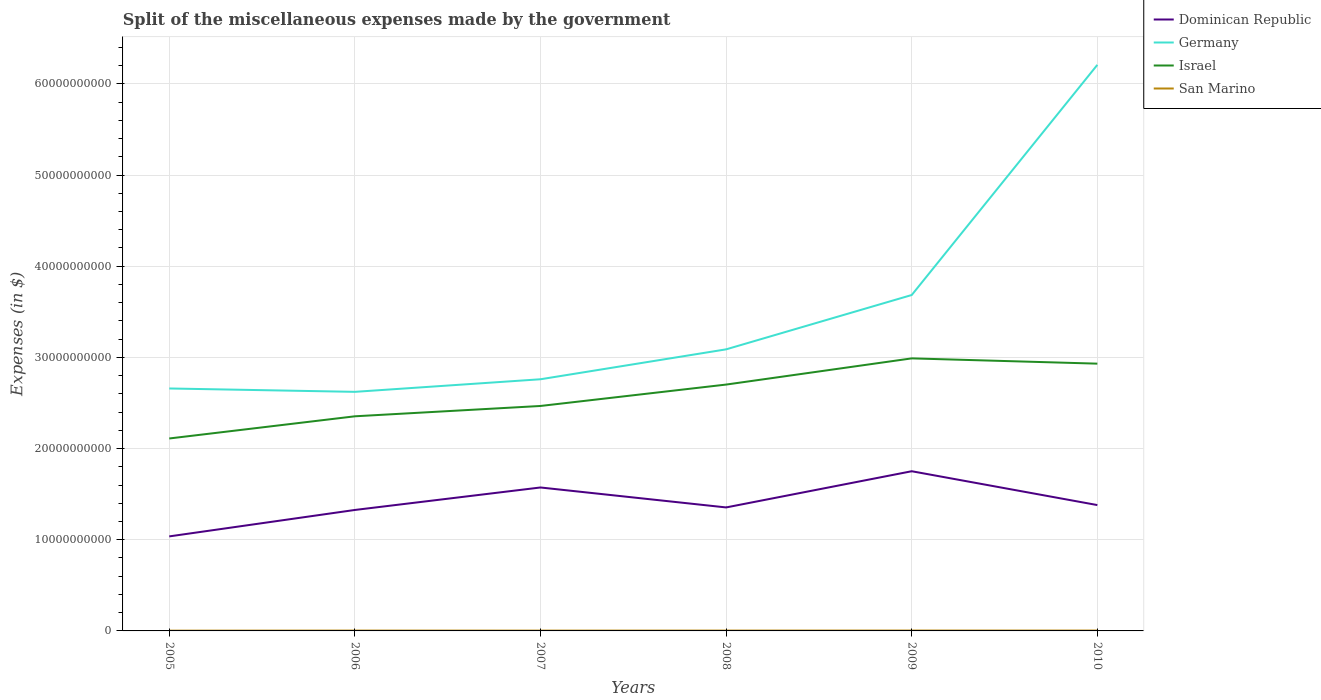Across all years, what is the maximum miscellaneous expenses made by the government in Dominican Republic?
Provide a succinct answer. 1.04e+1. In which year was the miscellaneous expenses made by the government in San Marino maximum?
Offer a very short reply. 2005. What is the total miscellaneous expenses made by the government in Germany in the graph?
Provide a short and direct response. 3.70e+08. What is the difference between the highest and the second highest miscellaneous expenses made by the government in Israel?
Offer a very short reply. 8.79e+09. What is the difference between the highest and the lowest miscellaneous expenses made by the government in Dominican Republic?
Provide a succinct answer. 2. Are the values on the major ticks of Y-axis written in scientific E-notation?
Give a very brief answer. No. Does the graph contain any zero values?
Your answer should be very brief. No. Where does the legend appear in the graph?
Offer a terse response. Top right. How are the legend labels stacked?
Offer a terse response. Vertical. What is the title of the graph?
Keep it short and to the point. Split of the miscellaneous expenses made by the government. What is the label or title of the X-axis?
Provide a short and direct response. Years. What is the label or title of the Y-axis?
Make the answer very short. Expenses (in $). What is the Expenses (in $) in Dominican Republic in 2005?
Your answer should be compact. 1.04e+1. What is the Expenses (in $) in Germany in 2005?
Keep it short and to the point. 2.66e+1. What is the Expenses (in $) in Israel in 2005?
Offer a terse response. 2.11e+1. What is the Expenses (in $) in San Marino in 2005?
Offer a very short reply. 2.95e+07. What is the Expenses (in $) of Dominican Republic in 2006?
Ensure brevity in your answer.  1.33e+1. What is the Expenses (in $) in Germany in 2006?
Your answer should be compact. 2.62e+1. What is the Expenses (in $) of Israel in 2006?
Ensure brevity in your answer.  2.35e+1. What is the Expenses (in $) in San Marino in 2006?
Provide a short and direct response. 3.73e+07. What is the Expenses (in $) in Dominican Republic in 2007?
Your answer should be very brief. 1.57e+1. What is the Expenses (in $) in Germany in 2007?
Your answer should be compact. 2.76e+1. What is the Expenses (in $) in Israel in 2007?
Provide a short and direct response. 2.47e+1. What is the Expenses (in $) in San Marino in 2007?
Your response must be concise. 3.50e+07. What is the Expenses (in $) in Dominican Republic in 2008?
Your answer should be very brief. 1.35e+1. What is the Expenses (in $) of Germany in 2008?
Offer a very short reply. 3.09e+1. What is the Expenses (in $) of Israel in 2008?
Provide a short and direct response. 2.70e+1. What is the Expenses (in $) in San Marino in 2008?
Your response must be concise. 3.81e+07. What is the Expenses (in $) of Dominican Republic in 2009?
Offer a terse response. 1.75e+1. What is the Expenses (in $) of Germany in 2009?
Ensure brevity in your answer.  3.68e+1. What is the Expenses (in $) in Israel in 2009?
Your answer should be compact. 2.99e+1. What is the Expenses (in $) of San Marino in 2009?
Offer a terse response. 4.16e+07. What is the Expenses (in $) in Dominican Republic in 2010?
Your response must be concise. 1.38e+1. What is the Expenses (in $) in Germany in 2010?
Offer a terse response. 6.21e+1. What is the Expenses (in $) in Israel in 2010?
Your answer should be very brief. 2.93e+1. What is the Expenses (in $) in San Marino in 2010?
Your response must be concise. 4.00e+07. Across all years, what is the maximum Expenses (in $) in Dominican Republic?
Offer a very short reply. 1.75e+1. Across all years, what is the maximum Expenses (in $) of Germany?
Ensure brevity in your answer.  6.21e+1. Across all years, what is the maximum Expenses (in $) of Israel?
Offer a terse response. 2.99e+1. Across all years, what is the maximum Expenses (in $) of San Marino?
Give a very brief answer. 4.16e+07. Across all years, what is the minimum Expenses (in $) of Dominican Republic?
Make the answer very short. 1.04e+1. Across all years, what is the minimum Expenses (in $) in Germany?
Provide a short and direct response. 2.62e+1. Across all years, what is the minimum Expenses (in $) in Israel?
Ensure brevity in your answer.  2.11e+1. Across all years, what is the minimum Expenses (in $) in San Marino?
Your answer should be compact. 2.95e+07. What is the total Expenses (in $) of Dominican Republic in the graph?
Give a very brief answer. 8.42e+1. What is the total Expenses (in $) in Germany in the graph?
Provide a short and direct response. 2.10e+11. What is the total Expenses (in $) in Israel in the graph?
Offer a very short reply. 1.56e+11. What is the total Expenses (in $) of San Marino in the graph?
Your answer should be compact. 2.22e+08. What is the difference between the Expenses (in $) in Dominican Republic in 2005 and that in 2006?
Offer a very short reply. -2.90e+09. What is the difference between the Expenses (in $) of Germany in 2005 and that in 2006?
Provide a succinct answer. 3.70e+08. What is the difference between the Expenses (in $) of Israel in 2005 and that in 2006?
Keep it short and to the point. -2.43e+09. What is the difference between the Expenses (in $) in San Marino in 2005 and that in 2006?
Offer a terse response. -7.72e+06. What is the difference between the Expenses (in $) in Dominican Republic in 2005 and that in 2007?
Your answer should be compact. -5.36e+09. What is the difference between the Expenses (in $) in Germany in 2005 and that in 2007?
Offer a terse response. -1.01e+09. What is the difference between the Expenses (in $) of Israel in 2005 and that in 2007?
Your answer should be compact. -3.57e+09. What is the difference between the Expenses (in $) in San Marino in 2005 and that in 2007?
Ensure brevity in your answer.  -5.46e+06. What is the difference between the Expenses (in $) of Dominican Republic in 2005 and that in 2008?
Provide a short and direct response. -3.18e+09. What is the difference between the Expenses (in $) in Germany in 2005 and that in 2008?
Offer a terse response. -4.29e+09. What is the difference between the Expenses (in $) in Israel in 2005 and that in 2008?
Your answer should be very brief. -5.91e+09. What is the difference between the Expenses (in $) in San Marino in 2005 and that in 2008?
Provide a succinct answer. -8.61e+06. What is the difference between the Expenses (in $) of Dominican Republic in 2005 and that in 2009?
Your answer should be very brief. -7.15e+09. What is the difference between the Expenses (in $) in Germany in 2005 and that in 2009?
Your answer should be compact. -1.02e+1. What is the difference between the Expenses (in $) in Israel in 2005 and that in 2009?
Your answer should be compact. -8.79e+09. What is the difference between the Expenses (in $) of San Marino in 2005 and that in 2009?
Provide a succinct answer. -1.21e+07. What is the difference between the Expenses (in $) of Dominican Republic in 2005 and that in 2010?
Your answer should be very brief. -3.43e+09. What is the difference between the Expenses (in $) of Germany in 2005 and that in 2010?
Offer a terse response. -3.55e+1. What is the difference between the Expenses (in $) of Israel in 2005 and that in 2010?
Ensure brevity in your answer.  -8.21e+09. What is the difference between the Expenses (in $) in San Marino in 2005 and that in 2010?
Your answer should be very brief. -1.05e+07. What is the difference between the Expenses (in $) in Dominican Republic in 2006 and that in 2007?
Ensure brevity in your answer.  -2.47e+09. What is the difference between the Expenses (in $) in Germany in 2006 and that in 2007?
Give a very brief answer. -1.38e+09. What is the difference between the Expenses (in $) of Israel in 2006 and that in 2007?
Keep it short and to the point. -1.13e+09. What is the difference between the Expenses (in $) of San Marino in 2006 and that in 2007?
Provide a succinct answer. 2.26e+06. What is the difference between the Expenses (in $) in Dominican Republic in 2006 and that in 2008?
Provide a short and direct response. -2.77e+08. What is the difference between the Expenses (in $) of Germany in 2006 and that in 2008?
Provide a short and direct response. -4.66e+09. What is the difference between the Expenses (in $) in Israel in 2006 and that in 2008?
Give a very brief answer. -3.48e+09. What is the difference between the Expenses (in $) in San Marino in 2006 and that in 2008?
Your answer should be very brief. -8.90e+05. What is the difference between the Expenses (in $) in Dominican Republic in 2006 and that in 2009?
Provide a succinct answer. -4.25e+09. What is the difference between the Expenses (in $) in Germany in 2006 and that in 2009?
Your answer should be compact. -1.06e+1. What is the difference between the Expenses (in $) of Israel in 2006 and that in 2009?
Provide a short and direct response. -6.35e+09. What is the difference between the Expenses (in $) in San Marino in 2006 and that in 2009?
Offer a very short reply. -4.37e+06. What is the difference between the Expenses (in $) in Dominican Republic in 2006 and that in 2010?
Ensure brevity in your answer.  -5.36e+08. What is the difference between the Expenses (in $) of Germany in 2006 and that in 2010?
Keep it short and to the point. -3.59e+1. What is the difference between the Expenses (in $) of Israel in 2006 and that in 2010?
Offer a very short reply. -5.77e+09. What is the difference between the Expenses (in $) of San Marino in 2006 and that in 2010?
Ensure brevity in your answer.  -2.76e+06. What is the difference between the Expenses (in $) in Dominican Republic in 2007 and that in 2008?
Make the answer very short. 2.19e+09. What is the difference between the Expenses (in $) of Germany in 2007 and that in 2008?
Give a very brief answer. -3.28e+09. What is the difference between the Expenses (in $) in Israel in 2007 and that in 2008?
Provide a succinct answer. -2.35e+09. What is the difference between the Expenses (in $) in San Marino in 2007 and that in 2008?
Ensure brevity in your answer.  -3.15e+06. What is the difference between the Expenses (in $) in Dominican Republic in 2007 and that in 2009?
Your answer should be very brief. -1.78e+09. What is the difference between the Expenses (in $) in Germany in 2007 and that in 2009?
Make the answer very short. -9.24e+09. What is the difference between the Expenses (in $) of Israel in 2007 and that in 2009?
Ensure brevity in your answer.  -5.22e+09. What is the difference between the Expenses (in $) in San Marino in 2007 and that in 2009?
Make the answer very short. -6.63e+06. What is the difference between the Expenses (in $) of Dominican Republic in 2007 and that in 2010?
Make the answer very short. 1.93e+09. What is the difference between the Expenses (in $) in Germany in 2007 and that in 2010?
Keep it short and to the point. -3.45e+1. What is the difference between the Expenses (in $) in Israel in 2007 and that in 2010?
Provide a short and direct response. -4.64e+09. What is the difference between the Expenses (in $) of San Marino in 2007 and that in 2010?
Your answer should be compact. -5.02e+06. What is the difference between the Expenses (in $) in Dominican Republic in 2008 and that in 2009?
Keep it short and to the point. -3.97e+09. What is the difference between the Expenses (in $) in Germany in 2008 and that in 2009?
Your answer should be very brief. -5.96e+09. What is the difference between the Expenses (in $) in Israel in 2008 and that in 2009?
Your answer should be compact. -2.87e+09. What is the difference between the Expenses (in $) in San Marino in 2008 and that in 2009?
Offer a very short reply. -3.48e+06. What is the difference between the Expenses (in $) of Dominican Republic in 2008 and that in 2010?
Your answer should be compact. -2.59e+08. What is the difference between the Expenses (in $) in Germany in 2008 and that in 2010?
Ensure brevity in your answer.  -3.12e+1. What is the difference between the Expenses (in $) of Israel in 2008 and that in 2010?
Make the answer very short. -2.29e+09. What is the difference between the Expenses (in $) in San Marino in 2008 and that in 2010?
Keep it short and to the point. -1.87e+06. What is the difference between the Expenses (in $) in Dominican Republic in 2009 and that in 2010?
Ensure brevity in your answer.  3.71e+09. What is the difference between the Expenses (in $) of Germany in 2009 and that in 2010?
Keep it short and to the point. -2.52e+1. What is the difference between the Expenses (in $) in Israel in 2009 and that in 2010?
Your answer should be compact. 5.78e+08. What is the difference between the Expenses (in $) of San Marino in 2009 and that in 2010?
Ensure brevity in your answer.  1.61e+06. What is the difference between the Expenses (in $) in Dominican Republic in 2005 and the Expenses (in $) in Germany in 2006?
Offer a very short reply. -1.59e+1. What is the difference between the Expenses (in $) of Dominican Republic in 2005 and the Expenses (in $) of Israel in 2006?
Ensure brevity in your answer.  -1.32e+1. What is the difference between the Expenses (in $) of Dominican Republic in 2005 and the Expenses (in $) of San Marino in 2006?
Your answer should be very brief. 1.03e+1. What is the difference between the Expenses (in $) in Germany in 2005 and the Expenses (in $) in Israel in 2006?
Offer a terse response. 3.05e+09. What is the difference between the Expenses (in $) of Germany in 2005 and the Expenses (in $) of San Marino in 2006?
Ensure brevity in your answer.  2.66e+1. What is the difference between the Expenses (in $) of Israel in 2005 and the Expenses (in $) of San Marino in 2006?
Provide a succinct answer. 2.11e+1. What is the difference between the Expenses (in $) of Dominican Republic in 2005 and the Expenses (in $) of Germany in 2007?
Keep it short and to the point. -1.72e+1. What is the difference between the Expenses (in $) in Dominican Republic in 2005 and the Expenses (in $) in Israel in 2007?
Your answer should be very brief. -1.43e+1. What is the difference between the Expenses (in $) of Dominican Republic in 2005 and the Expenses (in $) of San Marino in 2007?
Provide a succinct answer. 1.03e+1. What is the difference between the Expenses (in $) of Germany in 2005 and the Expenses (in $) of Israel in 2007?
Ensure brevity in your answer.  1.92e+09. What is the difference between the Expenses (in $) of Germany in 2005 and the Expenses (in $) of San Marino in 2007?
Your answer should be very brief. 2.66e+1. What is the difference between the Expenses (in $) in Israel in 2005 and the Expenses (in $) in San Marino in 2007?
Provide a short and direct response. 2.11e+1. What is the difference between the Expenses (in $) in Dominican Republic in 2005 and the Expenses (in $) in Germany in 2008?
Provide a short and direct response. -2.05e+1. What is the difference between the Expenses (in $) in Dominican Republic in 2005 and the Expenses (in $) in Israel in 2008?
Your answer should be compact. -1.67e+1. What is the difference between the Expenses (in $) of Dominican Republic in 2005 and the Expenses (in $) of San Marino in 2008?
Ensure brevity in your answer.  1.03e+1. What is the difference between the Expenses (in $) of Germany in 2005 and the Expenses (in $) of Israel in 2008?
Ensure brevity in your answer.  -4.28e+08. What is the difference between the Expenses (in $) of Germany in 2005 and the Expenses (in $) of San Marino in 2008?
Provide a succinct answer. 2.66e+1. What is the difference between the Expenses (in $) of Israel in 2005 and the Expenses (in $) of San Marino in 2008?
Keep it short and to the point. 2.11e+1. What is the difference between the Expenses (in $) of Dominican Republic in 2005 and the Expenses (in $) of Germany in 2009?
Provide a succinct answer. -2.65e+1. What is the difference between the Expenses (in $) of Dominican Republic in 2005 and the Expenses (in $) of Israel in 2009?
Offer a terse response. -1.95e+1. What is the difference between the Expenses (in $) of Dominican Republic in 2005 and the Expenses (in $) of San Marino in 2009?
Your response must be concise. 1.03e+1. What is the difference between the Expenses (in $) of Germany in 2005 and the Expenses (in $) of Israel in 2009?
Provide a succinct answer. -3.30e+09. What is the difference between the Expenses (in $) in Germany in 2005 and the Expenses (in $) in San Marino in 2009?
Your answer should be very brief. 2.65e+1. What is the difference between the Expenses (in $) of Israel in 2005 and the Expenses (in $) of San Marino in 2009?
Offer a terse response. 2.11e+1. What is the difference between the Expenses (in $) in Dominican Republic in 2005 and the Expenses (in $) in Germany in 2010?
Provide a short and direct response. -5.17e+1. What is the difference between the Expenses (in $) of Dominican Republic in 2005 and the Expenses (in $) of Israel in 2010?
Give a very brief answer. -1.89e+1. What is the difference between the Expenses (in $) in Dominican Republic in 2005 and the Expenses (in $) in San Marino in 2010?
Offer a terse response. 1.03e+1. What is the difference between the Expenses (in $) in Germany in 2005 and the Expenses (in $) in Israel in 2010?
Your response must be concise. -2.72e+09. What is the difference between the Expenses (in $) in Germany in 2005 and the Expenses (in $) in San Marino in 2010?
Ensure brevity in your answer.  2.65e+1. What is the difference between the Expenses (in $) of Israel in 2005 and the Expenses (in $) of San Marino in 2010?
Your response must be concise. 2.11e+1. What is the difference between the Expenses (in $) in Dominican Republic in 2006 and the Expenses (in $) in Germany in 2007?
Your answer should be compact. -1.43e+1. What is the difference between the Expenses (in $) of Dominican Republic in 2006 and the Expenses (in $) of Israel in 2007?
Keep it short and to the point. -1.14e+1. What is the difference between the Expenses (in $) of Dominican Republic in 2006 and the Expenses (in $) of San Marino in 2007?
Ensure brevity in your answer.  1.32e+1. What is the difference between the Expenses (in $) of Germany in 2006 and the Expenses (in $) of Israel in 2007?
Provide a short and direct response. 1.55e+09. What is the difference between the Expenses (in $) of Germany in 2006 and the Expenses (in $) of San Marino in 2007?
Your answer should be very brief. 2.62e+1. What is the difference between the Expenses (in $) of Israel in 2006 and the Expenses (in $) of San Marino in 2007?
Provide a short and direct response. 2.35e+1. What is the difference between the Expenses (in $) of Dominican Republic in 2006 and the Expenses (in $) of Germany in 2008?
Offer a terse response. -1.76e+1. What is the difference between the Expenses (in $) of Dominican Republic in 2006 and the Expenses (in $) of Israel in 2008?
Your response must be concise. -1.38e+1. What is the difference between the Expenses (in $) in Dominican Republic in 2006 and the Expenses (in $) in San Marino in 2008?
Keep it short and to the point. 1.32e+1. What is the difference between the Expenses (in $) of Germany in 2006 and the Expenses (in $) of Israel in 2008?
Your answer should be very brief. -7.98e+08. What is the difference between the Expenses (in $) of Germany in 2006 and the Expenses (in $) of San Marino in 2008?
Give a very brief answer. 2.62e+1. What is the difference between the Expenses (in $) of Israel in 2006 and the Expenses (in $) of San Marino in 2008?
Ensure brevity in your answer.  2.35e+1. What is the difference between the Expenses (in $) of Dominican Republic in 2006 and the Expenses (in $) of Germany in 2009?
Ensure brevity in your answer.  -2.36e+1. What is the difference between the Expenses (in $) of Dominican Republic in 2006 and the Expenses (in $) of Israel in 2009?
Ensure brevity in your answer.  -1.66e+1. What is the difference between the Expenses (in $) of Dominican Republic in 2006 and the Expenses (in $) of San Marino in 2009?
Your response must be concise. 1.32e+1. What is the difference between the Expenses (in $) in Germany in 2006 and the Expenses (in $) in Israel in 2009?
Your response must be concise. -3.67e+09. What is the difference between the Expenses (in $) of Germany in 2006 and the Expenses (in $) of San Marino in 2009?
Give a very brief answer. 2.62e+1. What is the difference between the Expenses (in $) in Israel in 2006 and the Expenses (in $) in San Marino in 2009?
Provide a succinct answer. 2.35e+1. What is the difference between the Expenses (in $) of Dominican Republic in 2006 and the Expenses (in $) of Germany in 2010?
Offer a very short reply. -4.88e+1. What is the difference between the Expenses (in $) of Dominican Republic in 2006 and the Expenses (in $) of Israel in 2010?
Give a very brief answer. -1.60e+1. What is the difference between the Expenses (in $) of Dominican Republic in 2006 and the Expenses (in $) of San Marino in 2010?
Keep it short and to the point. 1.32e+1. What is the difference between the Expenses (in $) in Germany in 2006 and the Expenses (in $) in Israel in 2010?
Provide a short and direct response. -3.09e+09. What is the difference between the Expenses (in $) in Germany in 2006 and the Expenses (in $) in San Marino in 2010?
Give a very brief answer. 2.62e+1. What is the difference between the Expenses (in $) in Israel in 2006 and the Expenses (in $) in San Marino in 2010?
Your response must be concise. 2.35e+1. What is the difference between the Expenses (in $) in Dominican Republic in 2007 and the Expenses (in $) in Germany in 2008?
Provide a succinct answer. -1.51e+1. What is the difference between the Expenses (in $) in Dominican Republic in 2007 and the Expenses (in $) in Israel in 2008?
Provide a short and direct response. -1.13e+1. What is the difference between the Expenses (in $) of Dominican Republic in 2007 and the Expenses (in $) of San Marino in 2008?
Give a very brief answer. 1.57e+1. What is the difference between the Expenses (in $) in Germany in 2007 and the Expenses (in $) in Israel in 2008?
Provide a succinct answer. 5.82e+08. What is the difference between the Expenses (in $) in Germany in 2007 and the Expenses (in $) in San Marino in 2008?
Offer a very short reply. 2.76e+1. What is the difference between the Expenses (in $) of Israel in 2007 and the Expenses (in $) of San Marino in 2008?
Ensure brevity in your answer.  2.46e+1. What is the difference between the Expenses (in $) in Dominican Republic in 2007 and the Expenses (in $) in Germany in 2009?
Give a very brief answer. -2.11e+1. What is the difference between the Expenses (in $) in Dominican Republic in 2007 and the Expenses (in $) in Israel in 2009?
Keep it short and to the point. -1.42e+1. What is the difference between the Expenses (in $) in Dominican Republic in 2007 and the Expenses (in $) in San Marino in 2009?
Provide a short and direct response. 1.57e+1. What is the difference between the Expenses (in $) of Germany in 2007 and the Expenses (in $) of Israel in 2009?
Your answer should be very brief. -2.29e+09. What is the difference between the Expenses (in $) of Germany in 2007 and the Expenses (in $) of San Marino in 2009?
Your response must be concise. 2.76e+1. What is the difference between the Expenses (in $) in Israel in 2007 and the Expenses (in $) in San Marino in 2009?
Provide a short and direct response. 2.46e+1. What is the difference between the Expenses (in $) of Dominican Republic in 2007 and the Expenses (in $) of Germany in 2010?
Offer a very short reply. -4.63e+1. What is the difference between the Expenses (in $) of Dominican Republic in 2007 and the Expenses (in $) of Israel in 2010?
Provide a succinct answer. -1.36e+1. What is the difference between the Expenses (in $) of Dominican Republic in 2007 and the Expenses (in $) of San Marino in 2010?
Offer a terse response. 1.57e+1. What is the difference between the Expenses (in $) in Germany in 2007 and the Expenses (in $) in Israel in 2010?
Make the answer very short. -1.71e+09. What is the difference between the Expenses (in $) of Germany in 2007 and the Expenses (in $) of San Marino in 2010?
Your answer should be very brief. 2.76e+1. What is the difference between the Expenses (in $) of Israel in 2007 and the Expenses (in $) of San Marino in 2010?
Make the answer very short. 2.46e+1. What is the difference between the Expenses (in $) of Dominican Republic in 2008 and the Expenses (in $) of Germany in 2009?
Ensure brevity in your answer.  -2.33e+1. What is the difference between the Expenses (in $) of Dominican Republic in 2008 and the Expenses (in $) of Israel in 2009?
Make the answer very short. -1.63e+1. What is the difference between the Expenses (in $) of Dominican Republic in 2008 and the Expenses (in $) of San Marino in 2009?
Ensure brevity in your answer.  1.35e+1. What is the difference between the Expenses (in $) in Germany in 2008 and the Expenses (in $) in Israel in 2009?
Your answer should be compact. 9.90e+08. What is the difference between the Expenses (in $) of Germany in 2008 and the Expenses (in $) of San Marino in 2009?
Make the answer very short. 3.08e+1. What is the difference between the Expenses (in $) of Israel in 2008 and the Expenses (in $) of San Marino in 2009?
Make the answer very short. 2.70e+1. What is the difference between the Expenses (in $) in Dominican Republic in 2008 and the Expenses (in $) in Germany in 2010?
Keep it short and to the point. -4.85e+1. What is the difference between the Expenses (in $) in Dominican Republic in 2008 and the Expenses (in $) in Israel in 2010?
Ensure brevity in your answer.  -1.58e+1. What is the difference between the Expenses (in $) in Dominican Republic in 2008 and the Expenses (in $) in San Marino in 2010?
Ensure brevity in your answer.  1.35e+1. What is the difference between the Expenses (in $) in Germany in 2008 and the Expenses (in $) in Israel in 2010?
Your response must be concise. 1.57e+09. What is the difference between the Expenses (in $) in Germany in 2008 and the Expenses (in $) in San Marino in 2010?
Offer a very short reply. 3.08e+1. What is the difference between the Expenses (in $) of Israel in 2008 and the Expenses (in $) of San Marino in 2010?
Offer a very short reply. 2.70e+1. What is the difference between the Expenses (in $) in Dominican Republic in 2009 and the Expenses (in $) in Germany in 2010?
Make the answer very short. -4.46e+1. What is the difference between the Expenses (in $) of Dominican Republic in 2009 and the Expenses (in $) of Israel in 2010?
Keep it short and to the point. -1.18e+1. What is the difference between the Expenses (in $) in Dominican Republic in 2009 and the Expenses (in $) in San Marino in 2010?
Ensure brevity in your answer.  1.75e+1. What is the difference between the Expenses (in $) of Germany in 2009 and the Expenses (in $) of Israel in 2010?
Your answer should be compact. 7.53e+09. What is the difference between the Expenses (in $) of Germany in 2009 and the Expenses (in $) of San Marino in 2010?
Offer a very short reply. 3.68e+1. What is the difference between the Expenses (in $) in Israel in 2009 and the Expenses (in $) in San Marino in 2010?
Provide a short and direct response. 2.99e+1. What is the average Expenses (in $) of Dominican Republic per year?
Your response must be concise. 1.40e+1. What is the average Expenses (in $) in Germany per year?
Your response must be concise. 3.50e+1. What is the average Expenses (in $) in Israel per year?
Provide a short and direct response. 2.59e+1. What is the average Expenses (in $) of San Marino per year?
Provide a succinct answer. 3.69e+07. In the year 2005, what is the difference between the Expenses (in $) of Dominican Republic and Expenses (in $) of Germany?
Offer a terse response. -1.62e+1. In the year 2005, what is the difference between the Expenses (in $) of Dominican Republic and Expenses (in $) of Israel?
Make the answer very short. -1.07e+1. In the year 2005, what is the difference between the Expenses (in $) of Dominican Republic and Expenses (in $) of San Marino?
Offer a terse response. 1.03e+1. In the year 2005, what is the difference between the Expenses (in $) of Germany and Expenses (in $) of Israel?
Give a very brief answer. 5.48e+09. In the year 2005, what is the difference between the Expenses (in $) of Germany and Expenses (in $) of San Marino?
Make the answer very short. 2.66e+1. In the year 2005, what is the difference between the Expenses (in $) of Israel and Expenses (in $) of San Marino?
Ensure brevity in your answer.  2.11e+1. In the year 2006, what is the difference between the Expenses (in $) in Dominican Republic and Expenses (in $) in Germany?
Keep it short and to the point. -1.30e+1. In the year 2006, what is the difference between the Expenses (in $) of Dominican Republic and Expenses (in $) of Israel?
Provide a succinct answer. -1.03e+1. In the year 2006, what is the difference between the Expenses (in $) in Dominican Republic and Expenses (in $) in San Marino?
Keep it short and to the point. 1.32e+1. In the year 2006, what is the difference between the Expenses (in $) of Germany and Expenses (in $) of Israel?
Your answer should be very brief. 2.68e+09. In the year 2006, what is the difference between the Expenses (in $) in Germany and Expenses (in $) in San Marino?
Offer a terse response. 2.62e+1. In the year 2006, what is the difference between the Expenses (in $) in Israel and Expenses (in $) in San Marino?
Your answer should be very brief. 2.35e+1. In the year 2007, what is the difference between the Expenses (in $) in Dominican Republic and Expenses (in $) in Germany?
Provide a short and direct response. -1.19e+1. In the year 2007, what is the difference between the Expenses (in $) in Dominican Republic and Expenses (in $) in Israel?
Keep it short and to the point. -8.94e+09. In the year 2007, what is the difference between the Expenses (in $) of Dominican Republic and Expenses (in $) of San Marino?
Offer a terse response. 1.57e+1. In the year 2007, what is the difference between the Expenses (in $) of Germany and Expenses (in $) of Israel?
Provide a short and direct response. 2.93e+09. In the year 2007, what is the difference between the Expenses (in $) in Germany and Expenses (in $) in San Marino?
Offer a terse response. 2.76e+1. In the year 2007, what is the difference between the Expenses (in $) of Israel and Expenses (in $) of San Marino?
Your answer should be compact. 2.46e+1. In the year 2008, what is the difference between the Expenses (in $) in Dominican Republic and Expenses (in $) in Germany?
Give a very brief answer. -1.73e+1. In the year 2008, what is the difference between the Expenses (in $) in Dominican Republic and Expenses (in $) in Israel?
Your answer should be compact. -1.35e+1. In the year 2008, what is the difference between the Expenses (in $) of Dominican Republic and Expenses (in $) of San Marino?
Your answer should be compact. 1.35e+1. In the year 2008, what is the difference between the Expenses (in $) in Germany and Expenses (in $) in Israel?
Provide a short and direct response. 3.86e+09. In the year 2008, what is the difference between the Expenses (in $) in Germany and Expenses (in $) in San Marino?
Provide a succinct answer. 3.08e+1. In the year 2008, what is the difference between the Expenses (in $) in Israel and Expenses (in $) in San Marino?
Your answer should be compact. 2.70e+1. In the year 2009, what is the difference between the Expenses (in $) in Dominican Republic and Expenses (in $) in Germany?
Offer a very short reply. -1.93e+1. In the year 2009, what is the difference between the Expenses (in $) of Dominican Republic and Expenses (in $) of Israel?
Give a very brief answer. -1.24e+1. In the year 2009, what is the difference between the Expenses (in $) in Dominican Republic and Expenses (in $) in San Marino?
Your response must be concise. 1.75e+1. In the year 2009, what is the difference between the Expenses (in $) of Germany and Expenses (in $) of Israel?
Your answer should be compact. 6.95e+09. In the year 2009, what is the difference between the Expenses (in $) in Germany and Expenses (in $) in San Marino?
Ensure brevity in your answer.  3.68e+1. In the year 2009, what is the difference between the Expenses (in $) of Israel and Expenses (in $) of San Marino?
Give a very brief answer. 2.98e+1. In the year 2010, what is the difference between the Expenses (in $) of Dominican Republic and Expenses (in $) of Germany?
Offer a very short reply. -4.83e+1. In the year 2010, what is the difference between the Expenses (in $) in Dominican Republic and Expenses (in $) in Israel?
Offer a very short reply. -1.55e+1. In the year 2010, what is the difference between the Expenses (in $) in Dominican Republic and Expenses (in $) in San Marino?
Ensure brevity in your answer.  1.38e+1. In the year 2010, what is the difference between the Expenses (in $) of Germany and Expenses (in $) of Israel?
Your answer should be very brief. 3.28e+1. In the year 2010, what is the difference between the Expenses (in $) in Germany and Expenses (in $) in San Marino?
Your answer should be compact. 6.20e+1. In the year 2010, what is the difference between the Expenses (in $) in Israel and Expenses (in $) in San Marino?
Keep it short and to the point. 2.93e+1. What is the ratio of the Expenses (in $) of Dominican Republic in 2005 to that in 2006?
Make the answer very short. 0.78. What is the ratio of the Expenses (in $) of Germany in 2005 to that in 2006?
Your response must be concise. 1.01. What is the ratio of the Expenses (in $) in Israel in 2005 to that in 2006?
Ensure brevity in your answer.  0.9. What is the ratio of the Expenses (in $) of San Marino in 2005 to that in 2006?
Keep it short and to the point. 0.79. What is the ratio of the Expenses (in $) in Dominican Republic in 2005 to that in 2007?
Provide a succinct answer. 0.66. What is the ratio of the Expenses (in $) of Germany in 2005 to that in 2007?
Your answer should be very brief. 0.96. What is the ratio of the Expenses (in $) in Israel in 2005 to that in 2007?
Ensure brevity in your answer.  0.86. What is the ratio of the Expenses (in $) of San Marino in 2005 to that in 2007?
Offer a terse response. 0.84. What is the ratio of the Expenses (in $) in Dominican Republic in 2005 to that in 2008?
Offer a very short reply. 0.77. What is the ratio of the Expenses (in $) of Germany in 2005 to that in 2008?
Provide a short and direct response. 0.86. What is the ratio of the Expenses (in $) of Israel in 2005 to that in 2008?
Provide a short and direct response. 0.78. What is the ratio of the Expenses (in $) in San Marino in 2005 to that in 2008?
Provide a short and direct response. 0.77. What is the ratio of the Expenses (in $) of Dominican Republic in 2005 to that in 2009?
Your response must be concise. 0.59. What is the ratio of the Expenses (in $) in Germany in 2005 to that in 2009?
Offer a very short reply. 0.72. What is the ratio of the Expenses (in $) in Israel in 2005 to that in 2009?
Your answer should be very brief. 0.71. What is the ratio of the Expenses (in $) in San Marino in 2005 to that in 2009?
Your answer should be very brief. 0.71. What is the ratio of the Expenses (in $) of Dominican Republic in 2005 to that in 2010?
Offer a terse response. 0.75. What is the ratio of the Expenses (in $) of Germany in 2005 to that in 2010?
Offer a terse response. 0.43. What is the ratio of the Expenses (in $) of Israel in 2005 to that in 2010?
Keep it short and to the point. 0.72. What is the ratio of the Expenses (in $) of San Marino in 2005 to that in 2010?
Ensure brevity in your answer.  0.74. What is the ratio of the Expenses (in $) in Dominican Republic in 2006 to that in 2007?
Provide a succinct answer. 0.84. What is the ratio of the Expenses (in $) in Israel in 2006 to that in 2007?
Ensure brevity in your answer.  0.95. What is the ratio of the Expenses (in $) in San Marino in 2006 to that in 2007?
Ensure brevity in your answer.  1.06. What is the ratio of the Expenses (in $) of Dominican Republic in 2006 to that in 2008?
Your answer should be very brief. 0.98. What is the ratio of the Expenses (in $) of Germany in 2006 to that in 2008?
Your answer should be very brief. 0.85. What is the ratio of the Expenses (in $) of Israel in 2006 to that in 2008?
Make the answer very short. 0.87. What is the ratio of the Expenses (in $) in San Marino in 2006 to that in 2008?
Provide a short and direct response. 0.98. What is the ratio of the Expenses (in $) of Dominican Republic in 2006 to that in 2009?
Make the answer very short. 0.76. What is the ratio of the Expenses (in $) of Germany in 2006 to that in 2009?
Give a very brief answer. 0.71. What is the ratio of the Expenses (in $) of Israel in 2006 to that in 2009?
Ensure brevity in your answer.  0.79. What is the ratio of the Expenses (in $) of San Marino in 2006 to that in 2009?
Ensure brevity in your answer.  0.9. What is the ratio of the Expenses (in $) in Dominican Republic in 2006 to that in 2010?
Offer a terse response. 0.96. What is the ratio of the Expenses (in $) in Germany in 2006 to that in 2010?
Keep it short and to the point. 0.42. What is the ratio of the Expenses (in $) in Israel in 2006 to that in 2010?
Offer a very short reply. 0.8. What is the ratio of the Expenses (in $) of San Marino in 2006 to that in 2010?
Your answer should be compact. 0.93. What is the ratio of the Expenses (in $) of Dominican Republic in 2007 to that in 2008?
Your answer should be compact. 1.16. What is the ratio of the Expenses (in $) of Germany in 2007 to that in 2008?
Your response must be concise. 0.89. What is the ratio of the Expenses (in $) in Israel in 2007 to that in 2008?
Provide a succinct answer. 0.91. What is the ratio of the Expenses (in $) in San Marino in 2007 to that in 2008?
Your answer should be compact. 0.92. What is the ratio of the Expenses (in $) of Dominican Republic in 2007 to that in 2009?
Provide a short and direct response. 0.9. What is the ratio of the Expenses (in $) in Germany in 2007 to that in 2009?
Ensure brevity in your answer.  0.75. What is the ratio of the Expenses (in $) of Israel in 2007 to that in 2009?
Your answer should be compact. 0.83. What is the ratio of the Expenses (in $) of San Marino in 2007 to that in 2009?
Provide a succinct answer. 0.84. What is the ratio of the Expenses (in $) of Dominican Republic in 2007 to that in 2010?
Provide a short and direct response. 1.14. What is the ratio of the Expenses (in $) of Germany in 2007 to that in 2010?
Make the answer very short. 0.44. What is the ratio of the Expenses (in $) of Israel in 2007 to that in 2010?
Give a very brief answer. 0.84. What is the ratio of the Expenses (in $) of San Marino in 2007 to that in 2010?
Keep it short and to the point. 0.87. What is the ratio of the Expenses (in $) of Dominican Republic in 2008 to that in 2009?
Provide a succinct answer. 0.77. What is the ratio of the Expenses (in $) in Germany in 2008 to that in 2009?
Ensure brevity in your answer.  0.84. What is the ratio of the Expenses (in $) of Israel in 2008 to that in 2009?
Give a very brief answer. 0.9. What is the ratio of the Expenses (in $) of San Marino in 2008 to that in 2009?
Provide a succinct answer. 0.92. What is the ratio of the Expenses (in $) in Dominican Republic in 2008 to that in 2010?
Give a very brief answer. 0.98. What is the ratio of the Expenses (in $) of Germany in 2008 to that in 2010?
Your answer should be very brief. 0.5. What is the ratio of the Expenses (in $) in Israel in 2008 to that in 2010?
Provide a succinct answer. 0.92. What is the ratio of the Expenses (in $) in San Marino in 2008 to that in 2010?
Your answer should be compact. 0.95. What is the ratio of the Expenses (in $) of Dominican Republic in 2009 to that in 2010?
Make the answer very short. 1.27. What is the ratio of the Expenses (in $) of Germany in 2009 to that in 2010?
Give a very brief answer. 0.59. What is the ratio of the Expenses (in $) in Israel in 2009 to that in 2010?
Offer a terse response. 1.02. What is the ratio of the Expenses (in $) in San Marino in 2009 to that in 2010?
Provide a succinct answer. 1.04. What is the difference between the highest and the second highest Expenses (in $) of Dominican Republic?
Provide a succinct answer. 1.78e+09. What is the difference between the highest and the second highest Expenses (in $) of Germany?
Your response must be concise. 2.52e+1. What is the difference between the highest and the second highest Expenses (in $) of Israel?
Your response must be concise. 5.78e+08. What is the difference between the highest and the second highest Expenses (in $) in San Marino?
Provide a short and direct response. 1.61e+06. What is the difference between the highest and the lowest Expenses (in $) in Dominican Republic?
Give a very brief answer. 7.15e+09. What is the difference between the highest and the lowest Expenses (in $) in Germany?
Offer a terse response. 3.59e+1. What is the difference between the highest and the lowest Expenses (in $) of Israel?
Offer a terse response. 8.79e+09. What is the difference between the highest and the lowest Expenses (in $) of San Marino?
Your answer should be compact. 1.21e+07. 